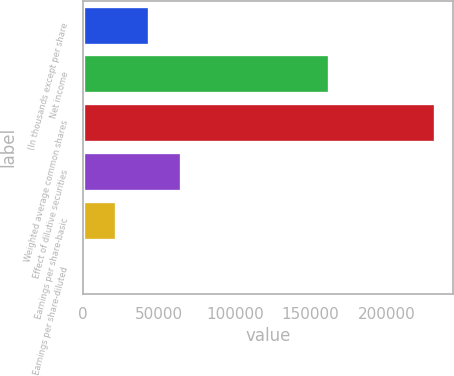<chart> <loc_0><loc_0><loc_500><loc_500><bar_chart><fcel>(In thousands except per share<fcel>Net income<fcel>Weighted average common shares<fcel>Effect of dilutive securities<fcel>Earnings per share-basic<fcel>Earnings per share-diluted<nl><fcel>43192.2<fcel>162330<fcel>232292<fcel>64787.9<fcel>21596.5<fcel>0.75<nl></chart> 